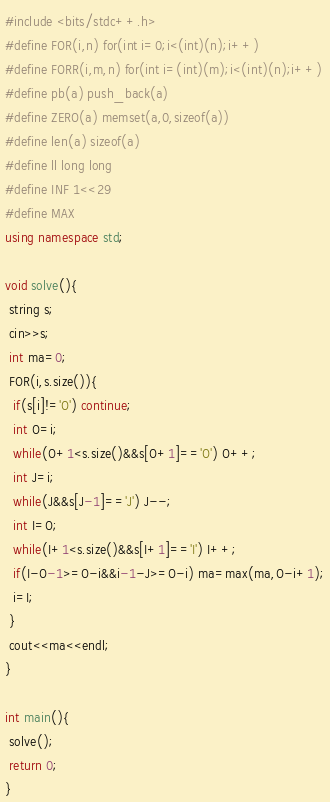Convert code to text. <code><loc_0><loc_0><loc_500><loc_500><_C++_>#include <bits/stdc++.h>
#define FOR(i,n) for(int i=0;i<(int)(n);i++)
#define FORR(i,m,n) for(int i=(int)(m);i<(int)(n);i++)
#define pb(a) push_back(a)
#define ZERO(a) memset(a,0,sizeof(a))
#define len(a) sizeof(a)
#define ll long long
#define INF 1<<29
#define MAX 
using namespace std;

void solve(){
 string s;
 cin>>s;
 int ma=0;
 FOR(i,s.size()){
  if(s[i]!='O') continue;
  int O=i;
  while(O+1<s.size()&&s[O+1]=='O') O++;
  int J=i;
  while(J&&s[J-1]=='J') J--;
  int I=O;
  while(I+1<s.size()&&s[I+1]=='I') I++;
  if(I-O-1>=O-i&&i-1-J>=O-i) ma=max(ma,O-i+1);
  i=I;
 }
 cout<<ma<<endl;
}

int main(){
 solve();
 return 0;
}</code> 